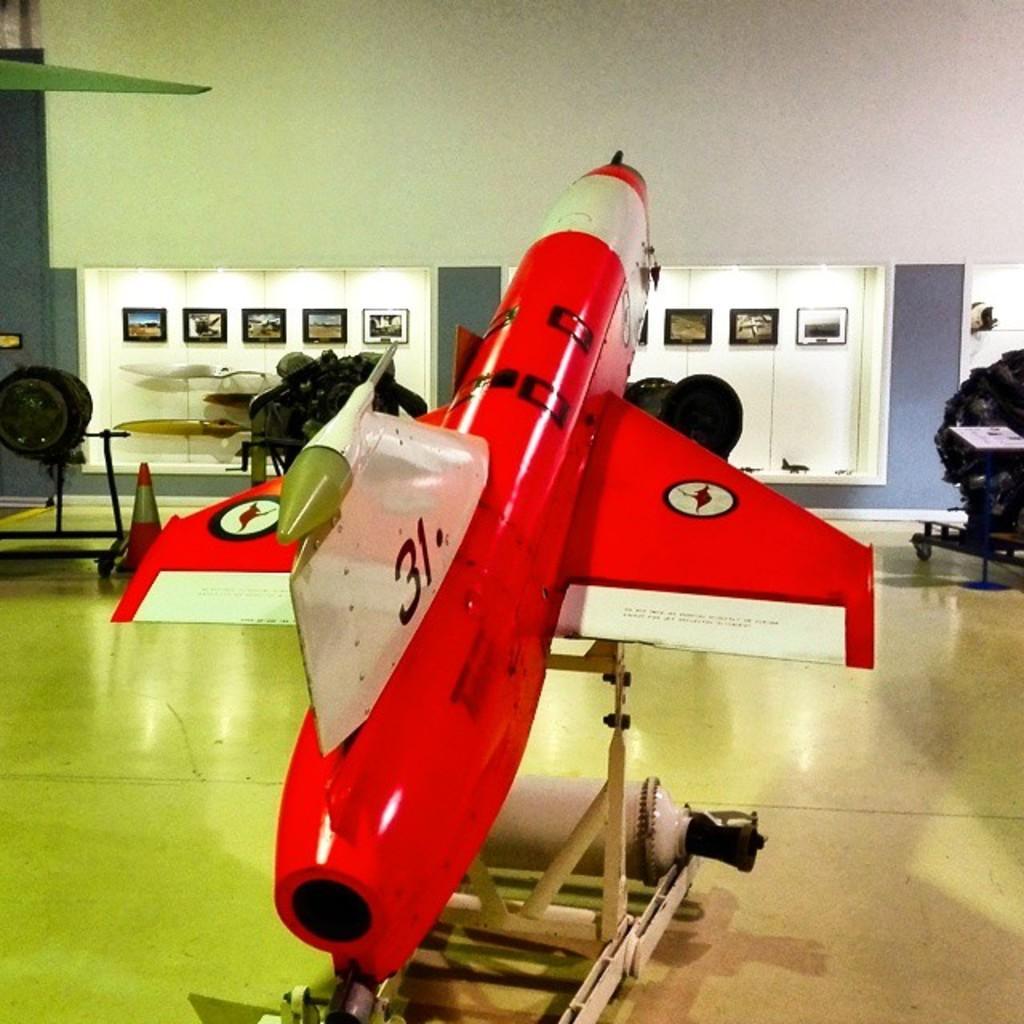Can you describe this image briefly? In this picture we can see an airplane, traffic cone, stand and some objects on the floor and in the background we can see frames, walls. 